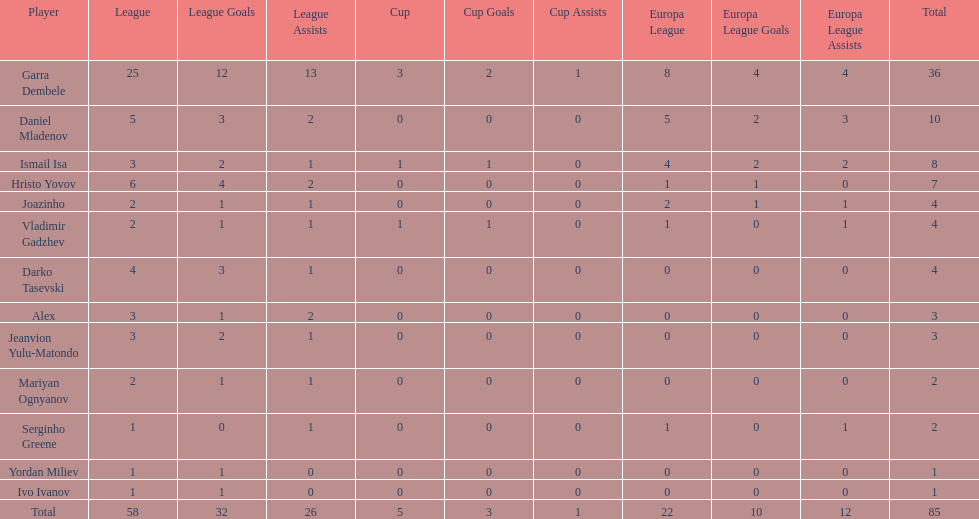Which is the only player from germany? Jeanvion Yulu-Matondo. 